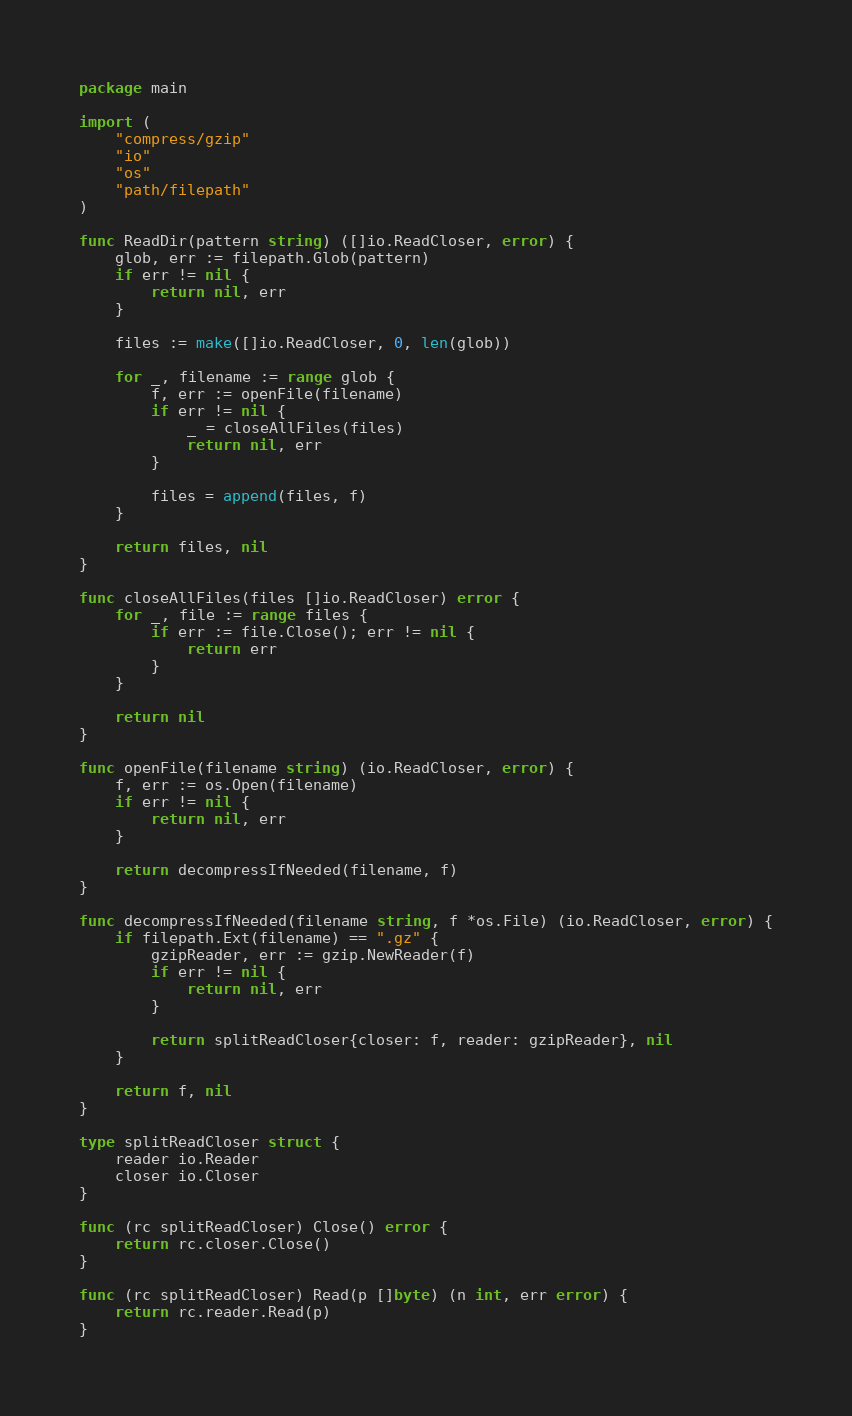Convert code to text. <code><loc_0><loc_0><loc_500><loc_500><_Go_>package main

import (
	"compress/gzip"
	"io"
	"os"
	"path/filepath"
)

func ReadDir(pattern string) ([]io.ReadCloser, error) {
	glob, err := filepath.Glob(pattern)
	if err != nil {
		return nil, err
	}

	files := make([]io.ReadCloser, 0, len(glob))

	for _, filename := range glob {
		f, err := openFile(filename)
		if err != nil {
			_ = closeAllFiles(files)
			return nil, err
		}

		files = append(files, f)
	}

	return files, nil
}

func closeAllFiles(files []io.ReadCloser) error {
	for _, file := range files {
		if err := file.Close(); err != nil {
			return err
		}
	}

	return nil
}

func openFile(filename string) (io.ReadCloser, error) {
	f, err := os.Open(filename)
	if err != nil {
		return nil, err
	}

	return decompressIfNeeded(filename, f)
}

func decompressIfNeeded(filename string, f *os.File) (io.ReadCloser, error) {
	if filepath.Ext(filename) == ".gz" {
		gzipReader, err := gzip.NewReader(f)
		if err != nil {
			return nil, err
		}

		return splitReadCloser{closer: f, reader: gzipReader}, nil
	}

	return f, nil
}

type splitReadCloser struct {
	reader io.Reader
	closer io.Closer
}

func (rc splitReadCloser) Close() error {
	return rc.closer.Close()
}

func (rc splitReadCloser) Read(p []byte) (n int, err error) {
	return rc.reader.Read(p)
}
</code> 